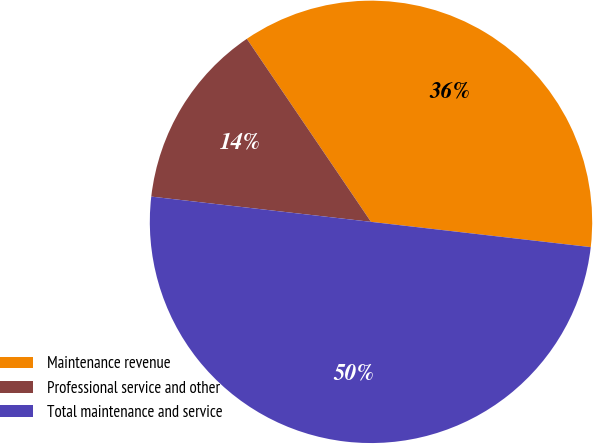<chart> <loc_0><loc_0><loc_500><loc_500><pie_chart><fcel>Maintenance revenue<fcel>Professional service and other<fcel>Total maintenance and service<nl><fcel>36.31%<fcel>13.69%<fcel>50.0%<nl></chart> 